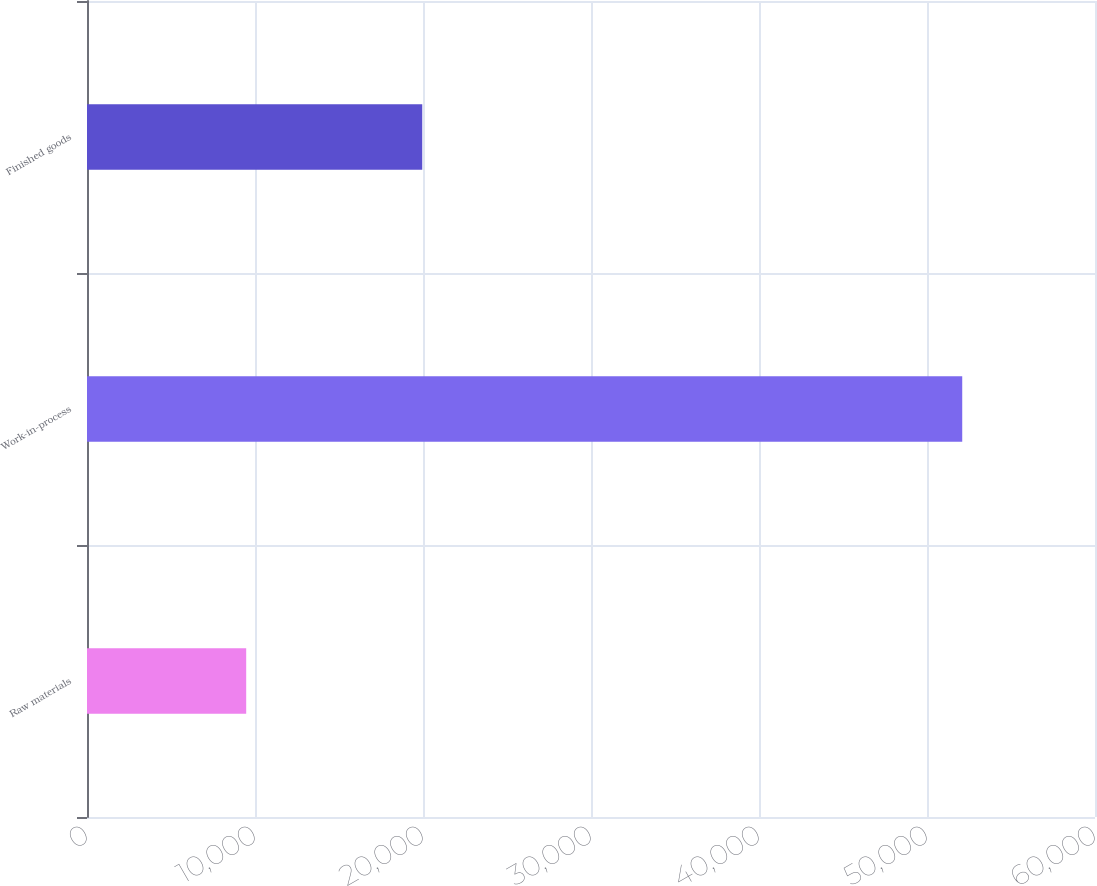<chart> <loc_0><loc_0><loc_500><loc_500><bar_chart><fcel>Raw materials<fcel>Work-in-process<fcel>Finished goods<nl><fcel>9476<fcel>52097<fcel>19956<nl></chart> 